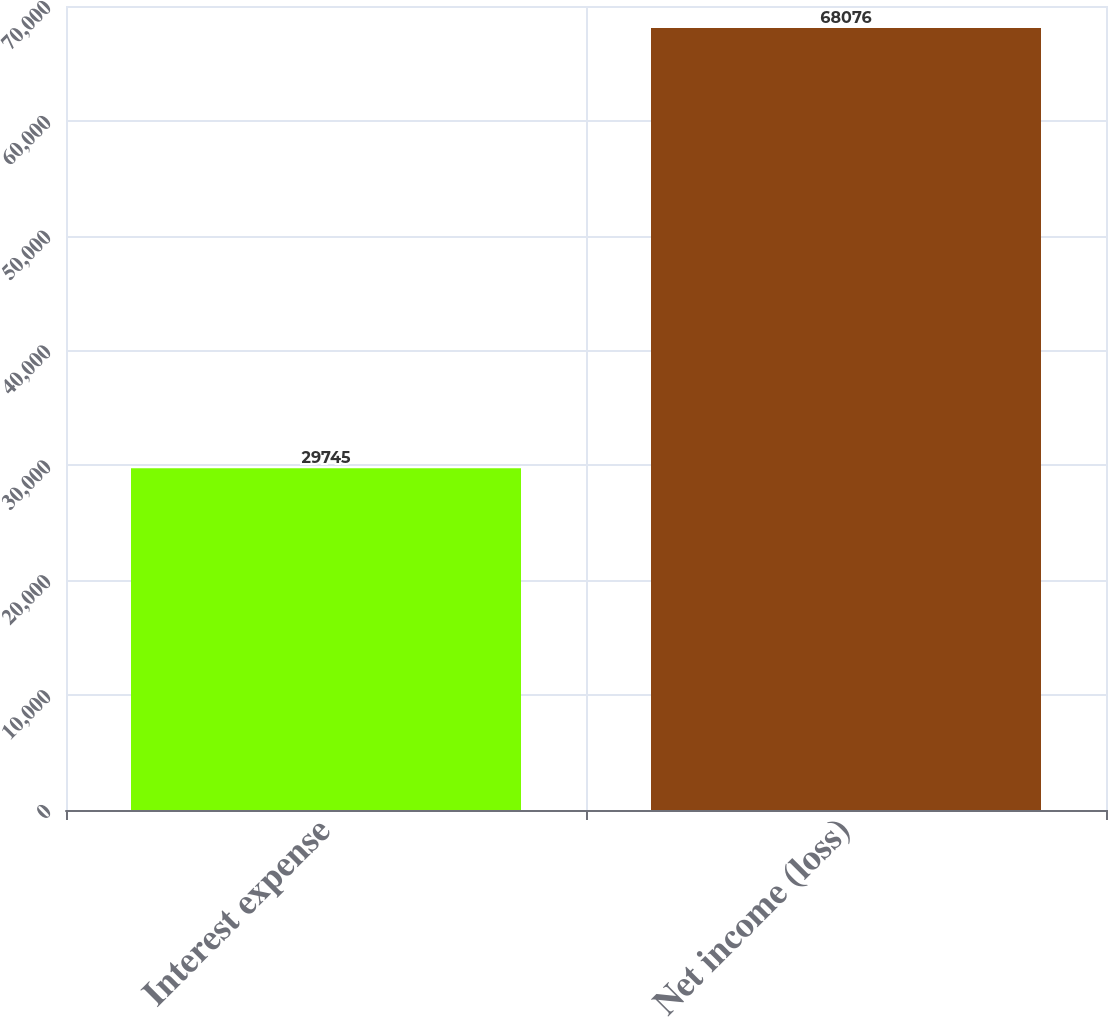Convert chart. <chart><loc_0><loc_0><loc_500><loc_500><bar_chart><fcel>Interest expense<fcel>Net income (loss)<nl><fcel>29745<fcel>68076<nl></chart> 